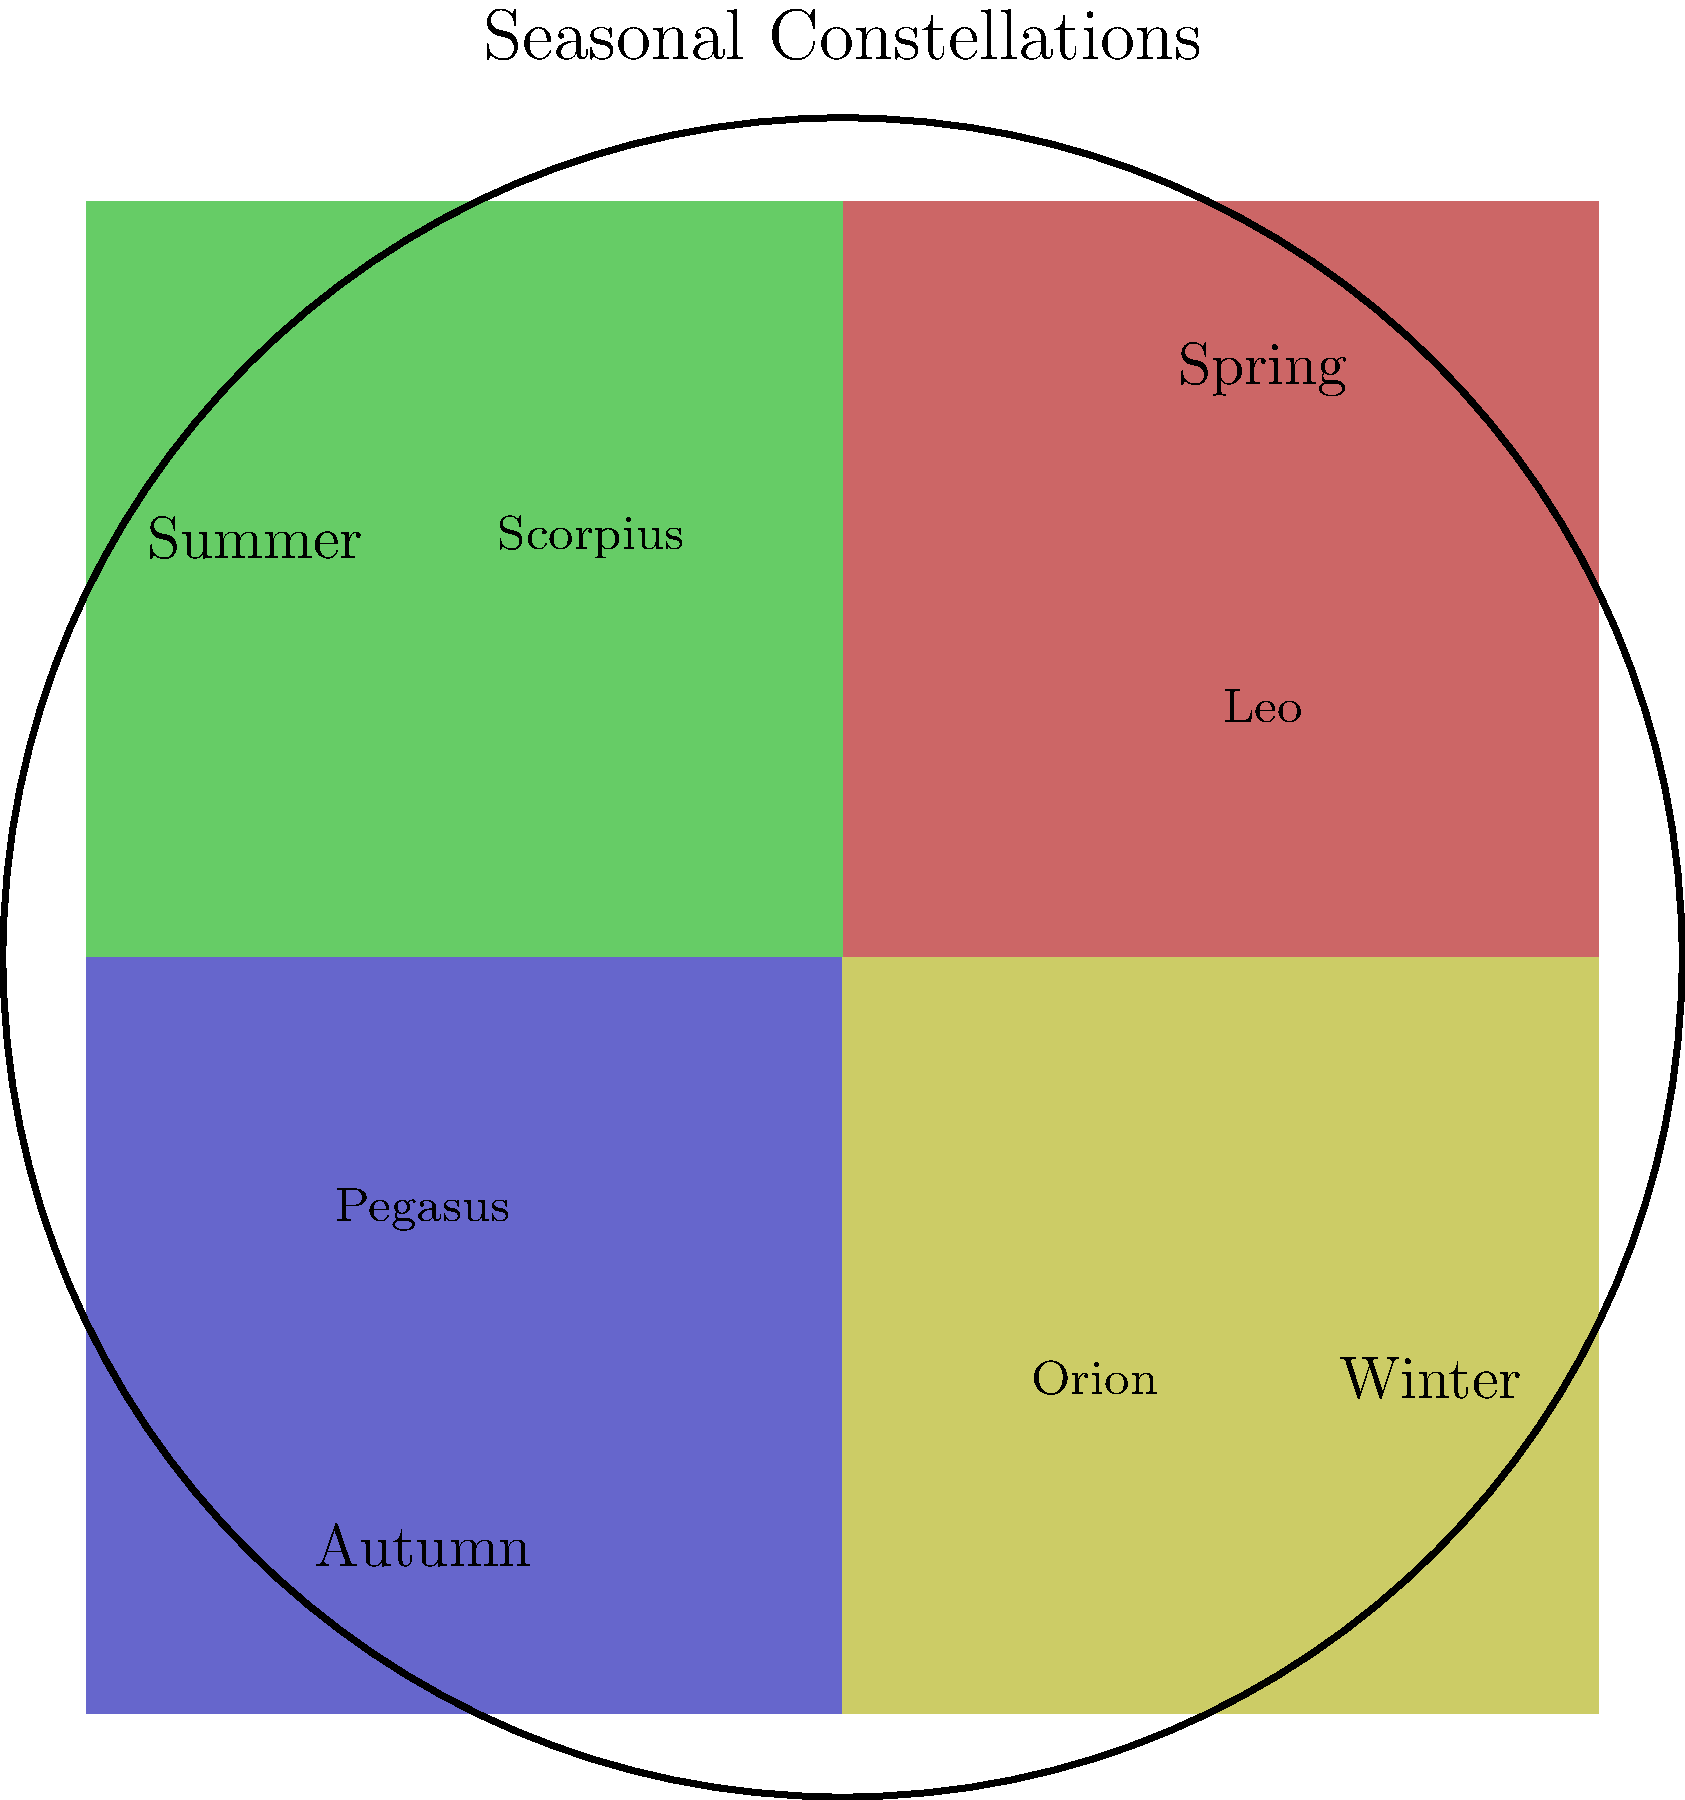In the context of cultural astronomy, which constellation visible during the winter months has been historically associated with hunting and has significant mythological importance across various cultures? To answer this question, let's consider the following steps:

1. Examine the seasonal constellations shown in the diagram:
   - Spring: Leo
   - Summer: Scorpius
   - Autumn: Pegasus
   - Winter: Orion

2. Focus on the winter constellation: Orion

3. Cultural significance of Orion:
   a) Hunting association: Orion is often depicted as a hunter in many cultures, with his belt and sword representing his hunting tools.
   b) Mythological importance:
      - Greek mythology: Orion was a giant huntsman placed among the stars by Zeus
      - Egyptian mythology: Associated with the god Osiris
      - Native American cultures: Often seen as a hunter or warrior figure
      - Chinese astronomy: Known as "Shen," or the "Three Stars," representing prosperity

4. Visibility: Orion is prominently visible in the night sky during winter months in the Northern Hemisphere, making it a significant marker of the season.

5. Cross-cultural recognition: The distinctive pattern of Orion's belt (three bright stars in a row) makes it easily recognizable across different cultures, contributing to its widespread mythological importance.

Given these factors, Orion stands out as the winter constellation with strong associations to hunting and significant cross-cultural mythological importance.
Answer: Orion 